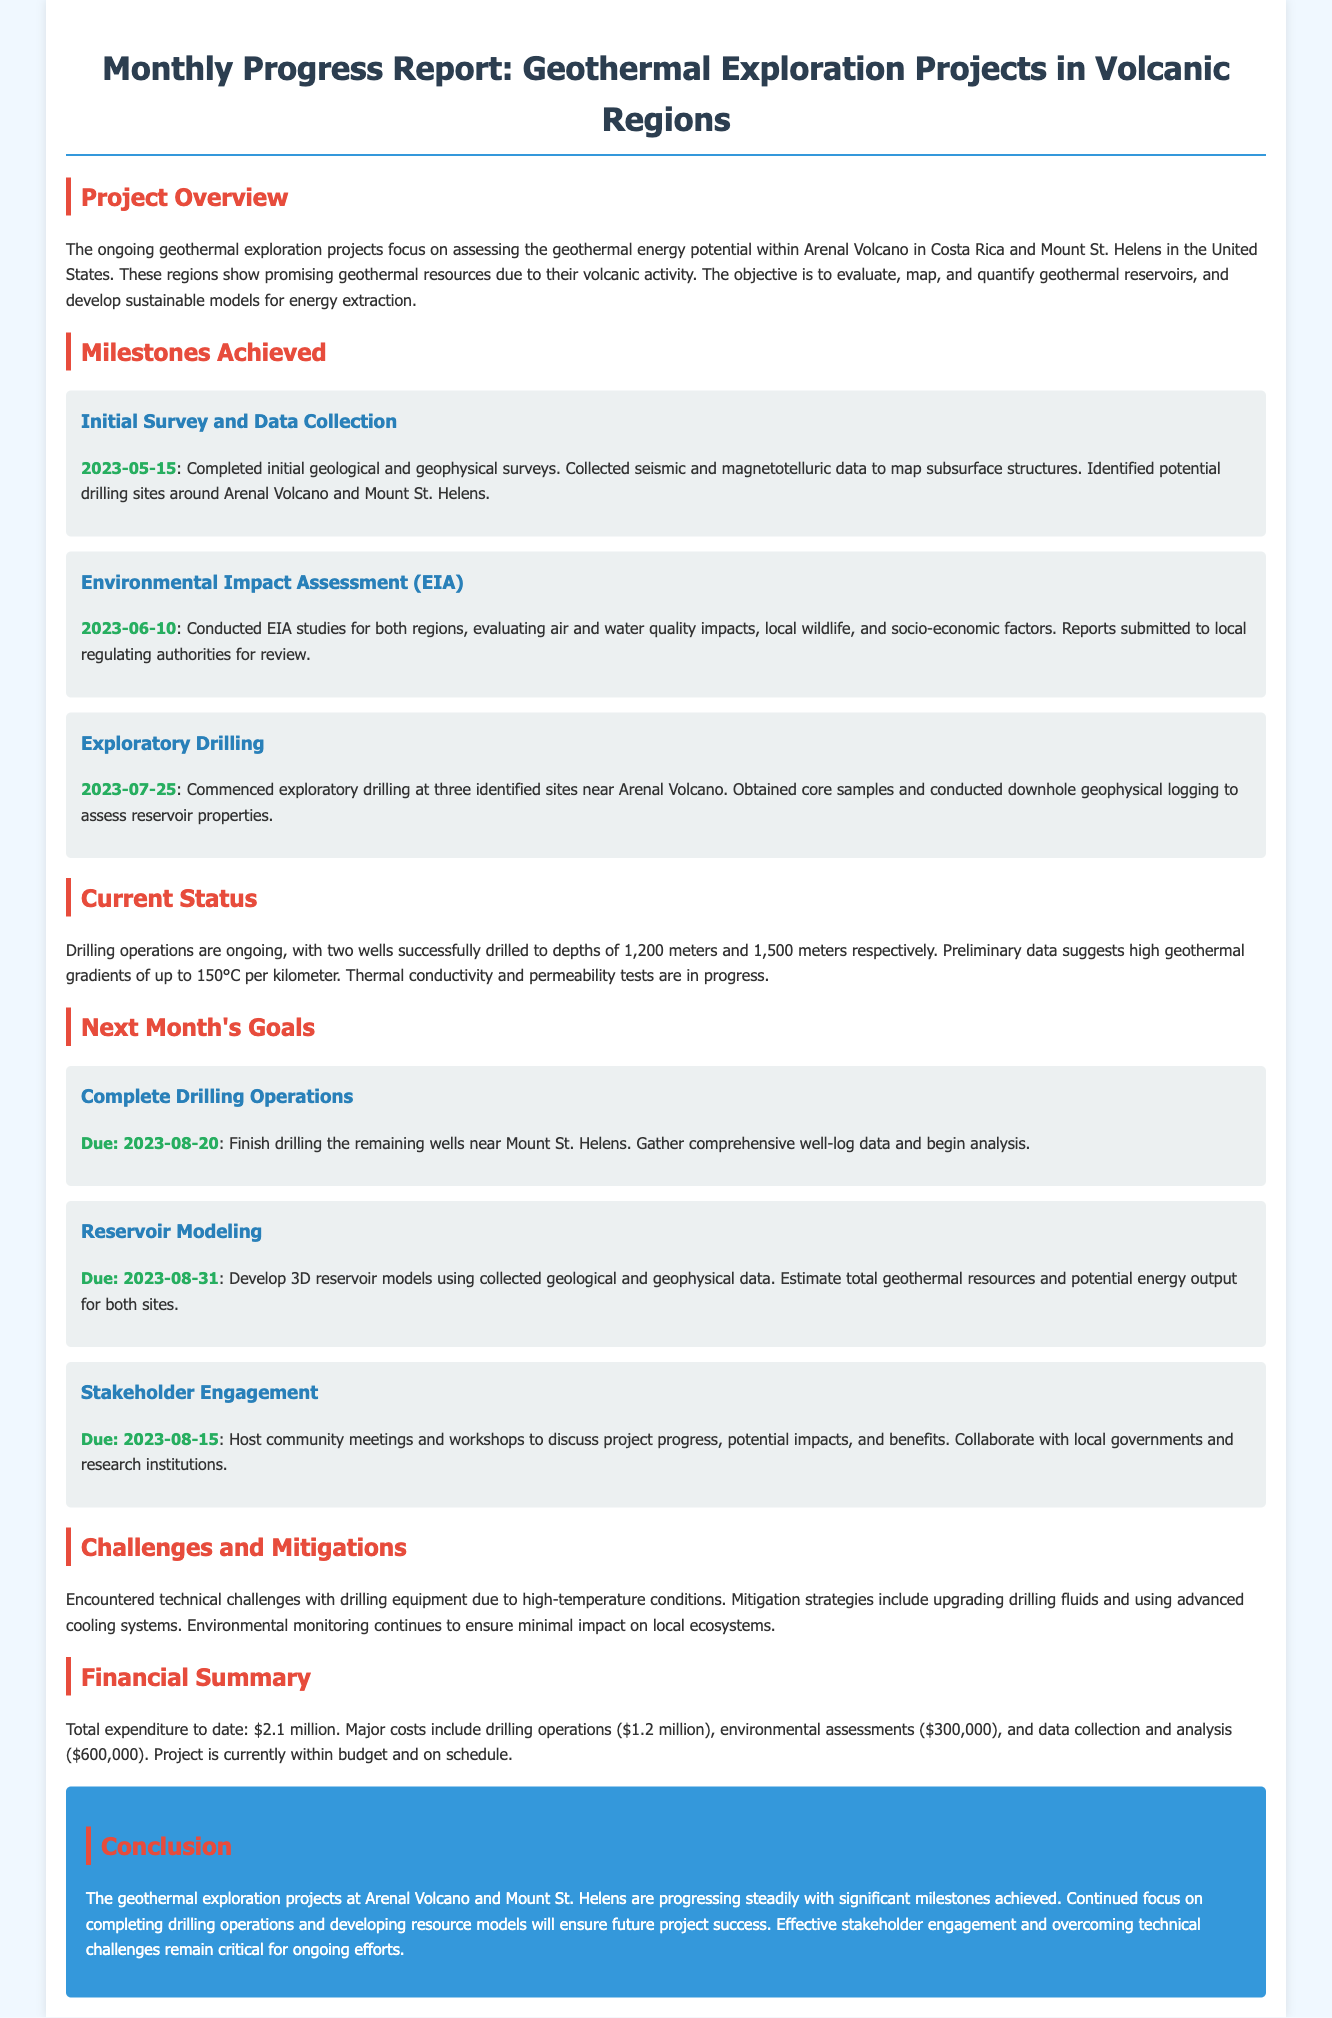What are the names of the two volcanic regions? The document mentions two locations for geothermal exploration, Arenal Volcano in Costa Rica and Mount St. Helens in the United States.
Answer: Arenal Volcano and Mount St. Helens What is the completion date of the Initial Survey and Data Collection? The milestone mentions the date when the initial survey was completed as May 15, 2023.
Answer: 2023-05-15 How many wells have been successfully drilled to date? The current status section states that two wells have been successfully drilled.
Answer: Two What is the due date for completing drilling operations? The next month's goals section specifies that completing drilling operations is due on August 20, 2023.
Answer: 2023-08-20 What was the total expenditure to date? The financial summary indicates that the total expenditure to date is $2.1 million.
Answer: $2.1 million What are the geothermal gradients reported? The current status mentions that preliminary data suggests high geothermal gradients of up to 150°C per kilometer.
Answer: 150°C What challenge was encountered during drilling operations? The document refers to technical challenges with drilling equipment due to high-temperature conditions.
Answer: High-temperature conditions What is one of the goals related to community engagement? One goal mentioned in the next month's goals is to host community meetings and workshops to discuss project progress.
Answer: Host community meetings and workshops What is the projected financial status of the project? The financial summary states that the project is currently within budget and on schedule.
Answer: Within budget and on schedule 